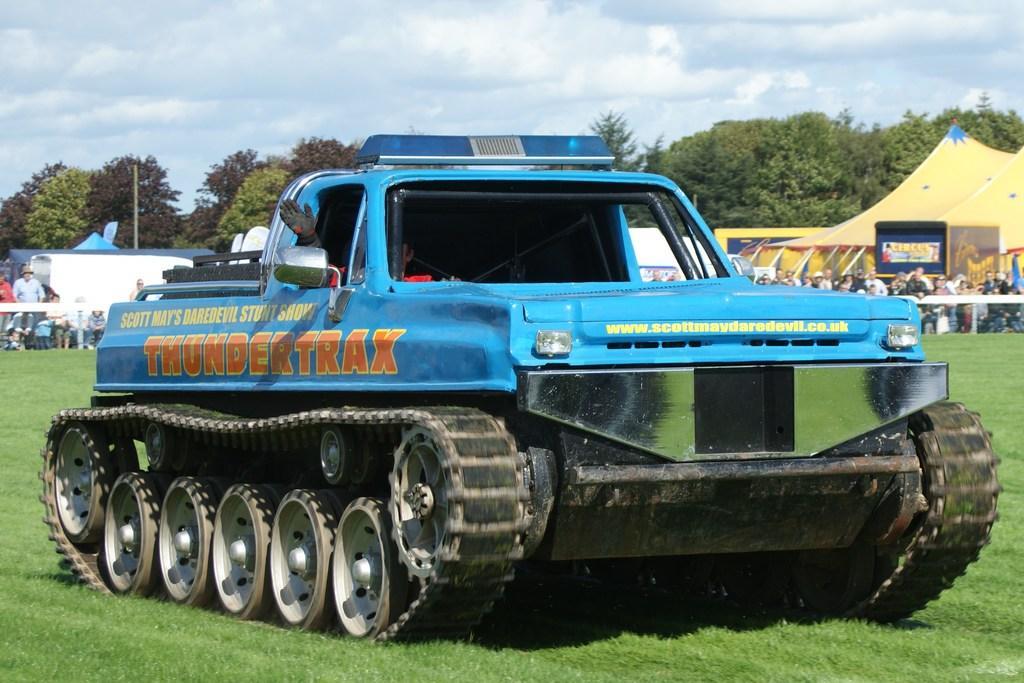Please provide a concise description of this image. In this image I can see the blue color vehicle on the grass. I can see one person is sitting inside the vehicle. In the background I can see many people with different color dresses. I can also see the tents. I can also see many trees, clouds and the sky in the back. 